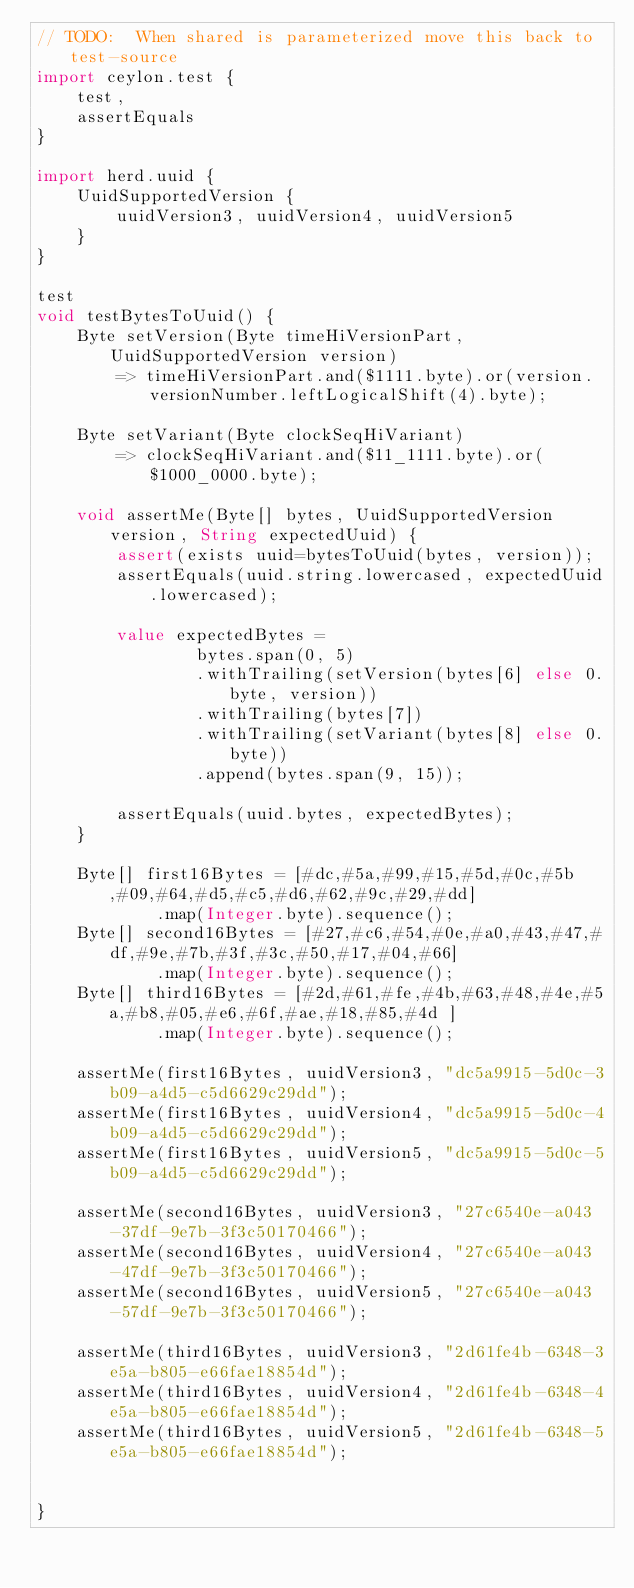Convert code to text. <code><loc_0><loc_0><loc_500><loc_500><_Ceylon_>// TODO:  When shared is parameterized move this back to test-source
import ceylon.test {
    test,
    assertEquals
}

import herd.uuid {
    UuidSupportedVersion {
        uuidVersion3, uuidVersion4, uuidVersion5
    }
}

test
void testBytesToUuid() {
    Byte setVersion(Byte timeHiVersionPart, UuidSupportedVersion version)
        => timeHiVersionPart.and($1111.byte).or(version.versionNumber.leftLogicalShift(4).byte);

    Byte setVariant(Byte clockSeqHiVariant)
        => clockSeqHiVariant.and($11_1111.byte).or($1000_0000.byte);

    void assertMe(Byte[] bytes, UuidSupportedVersion version, String expectedUuid) {
        assert(exists uuid=bytesToUuid(bytes, version));
        assertEquals(uuid.string.lowercased, expectedUuid.lowercased);

        value expectedBytes =
                bytes.span(0, 5)
                .withTrailing(setVersion(bytes[6] else 0.byte, version))
                .withTrailing(bytes[7])
                .withTrailing(setVariant(bytes[8] else 0.byte))
                .append(bytes.span(9, 15));

        assertEquals(uuid.bytes, expectedBytes);
    }

    Byte[] first16Bytes = [#dc,#5a,#99,#15,#5d,#0c,#5b,#09,#64,#d5,#c5,#d6,#62,#9c,#29,#dd]
            .map(Integer.byte).sequence();
    Byte[] second16Bytes = [#27,#c6,#54,#0e,#a0,#43,#47,#df,#9e,#7b,#3f,#3c,#50,#17,#04,#66]
            .map(Integer.byte).sequence();
    Byte[] third16Bytes = [#2d,#61,#fe,#4b,#63,#48,#4e,#5a,#b8,#05,#e6,#6f,#ae,#18,#85,#4d ]
            .map(Integer.byte).sequence();

    assertMe(first16Bytes, uuidVersion3, "dc5a9915-5d0c-3b09-a4d5-c5d6629c29dd");
    assertMe(first16Bytes, uuidVersion4, "dc5a9915-5d0c-4b09-a4d5-c5d6629c29dd");
    assertMe(first16Bytes, uuidVersion5, "dc5a9915-5d0c-5b09-a4d5-c5d6629c29dd");

    assertMe(second16Bytes, uuidVersion3, "27c6540e-a043-37df-9e7b-3f3c50170466");
    assertMe(second16Bytes, uuidVersion4, "27c6540e-a043-47df-9e7b-3f3c50170466");
    assertMe(second16Bytes, uuidVersion5, "27c6540e-a043-57df-9e7b-3f3c50170466");

    assertMe(third16Bytes, uuidVersion3, "2d61fe4b-6348-3e5a-b805-e66fae18854d");
    assertMe(third16Bytes, uuidVersion4, "2d61fe4b-6348-4e5a-b805-e66fae18854d");
    assertMe(third16Bytes, uuidVersion5, "2d61fe4b-6348-5e5a-b805-e66fae18854d");


}</code> 